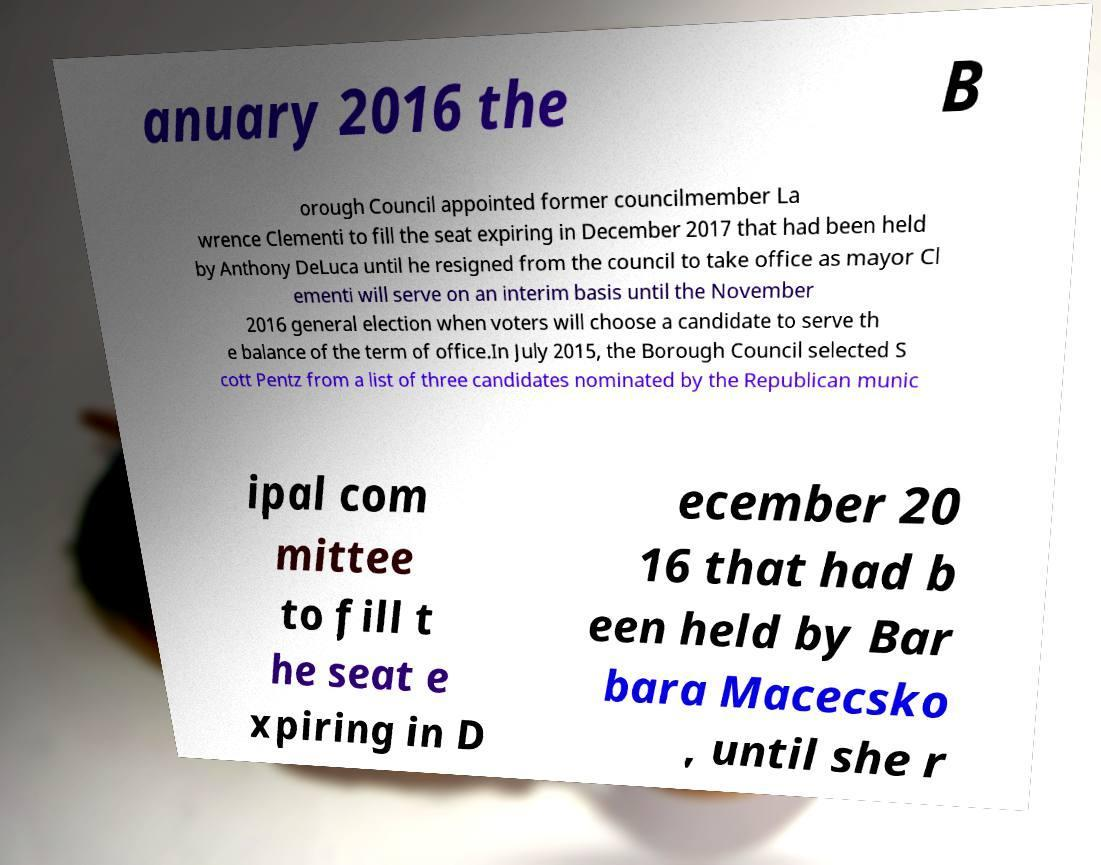What messages or text are displayed in this image? I need them in a readable, typed format. anuary 2016 the B orough Council appointed former councilmember La wrence Clementi to fill the seat expiring in December 2017 that had been held by Anthony DeLuca until he resigned from the council to take office as mayor Cl ementi will serve on an interim basis until the November 2016 general election when voters will choose a candidate to serve th e balance of the term of office.In July 2015, the Borough Council selected S cott Pentz from a list of three candidates nominated by the Republican munic ipal com mittee to fill t he seat e xpiring in D ecember 20 16 that had b een held by Bar bara Macecsko , until she r 